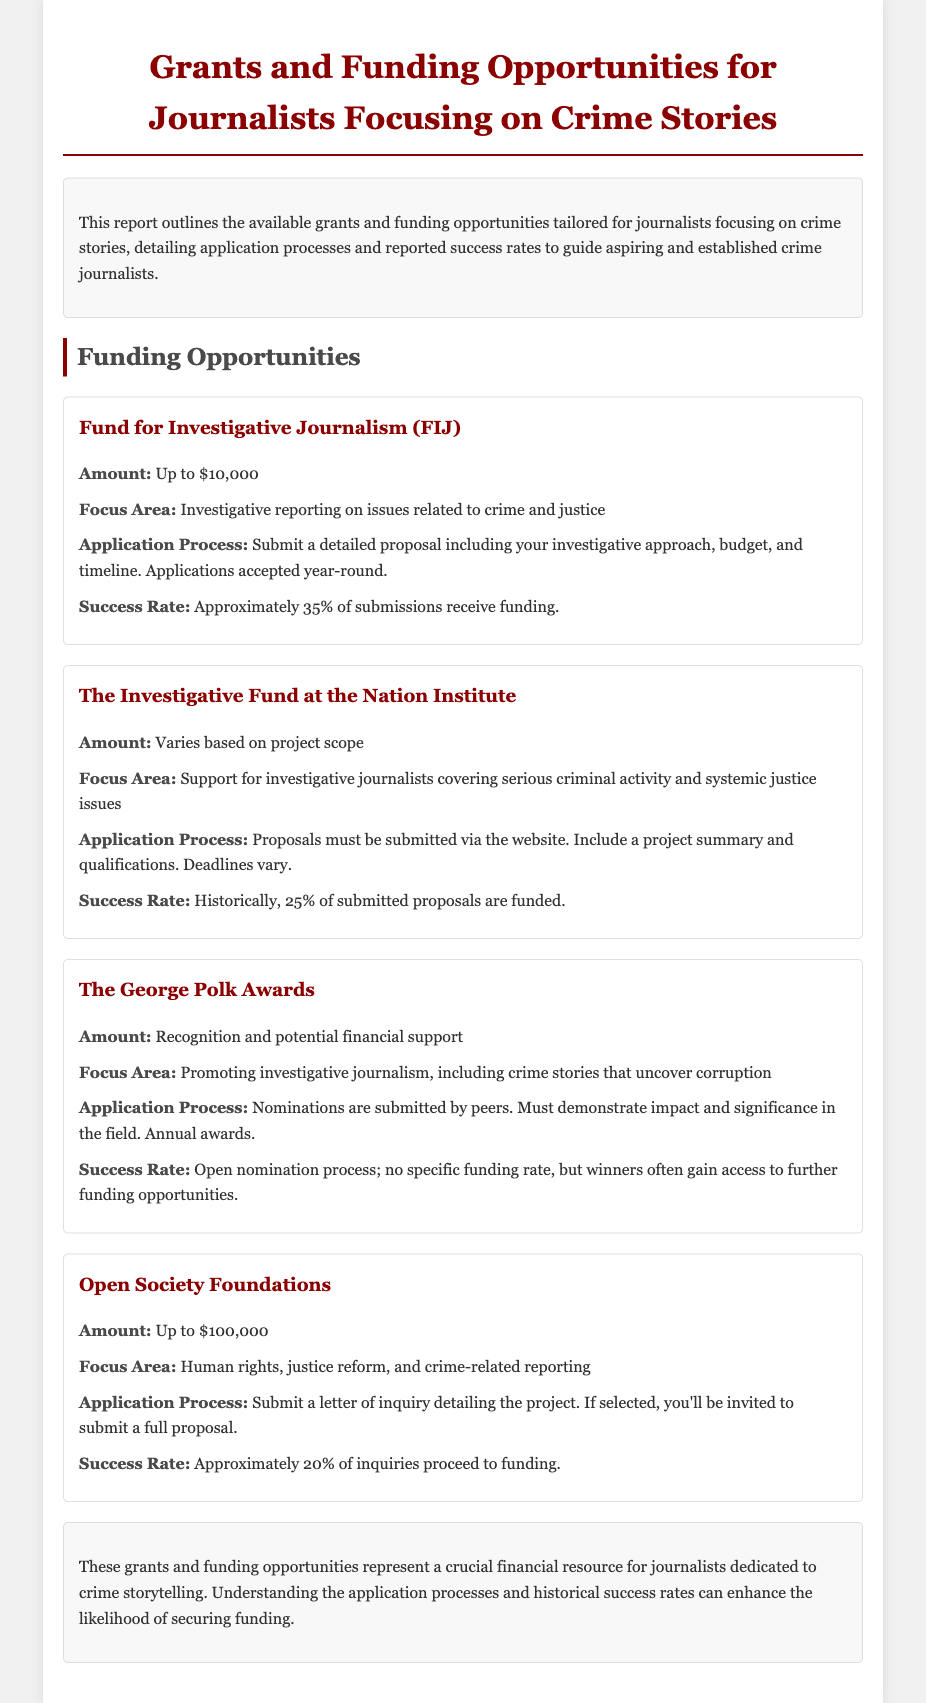What is the maximum funding amount from the Fund for Investigative Journalism? The Fund for Investigative Journalism offers funding of "Up to $10,000."
Answer: Up to $10,000 What is the focus area of the Open Society Foundations? The Open Society Foundations focus on "Human rights, justice reform, and crime-related reporting."
Answer: Human rights, justice reform, and crime-related reporting What percentage of submissions to the Investigative Fund are historically funded? The document states that "Historically, 25% of submitted proposals are funded."
Answer: 25% What is required for applying to the George Polk Awards? Nominations are submitted by peers and must demonstrate "impact and significance in the field."
Answer: Peers' nominations What is the reported success rate for inquiries submitted to the Open Society Foundations? Approximately "20% of inquiries proceed to funding."
Answer: 20% What should be included in the application for the Fund for Investigative Journalism? A detailed proposal including "investigative approach, budget, and timeline."
Answer: Investigative approach, budget, and timeline What are the deadlines for the Investigative Fund? "Deadlines vary" for submitting proposals to The Investigative Fund at the Nation Institute.
Answer: Varies What is the primary goal of the George Polk Awards? The awards aim at "Promoting investigative journalism, including crime stories that uncover corruption."
Answer: Promoting investigative journalism 